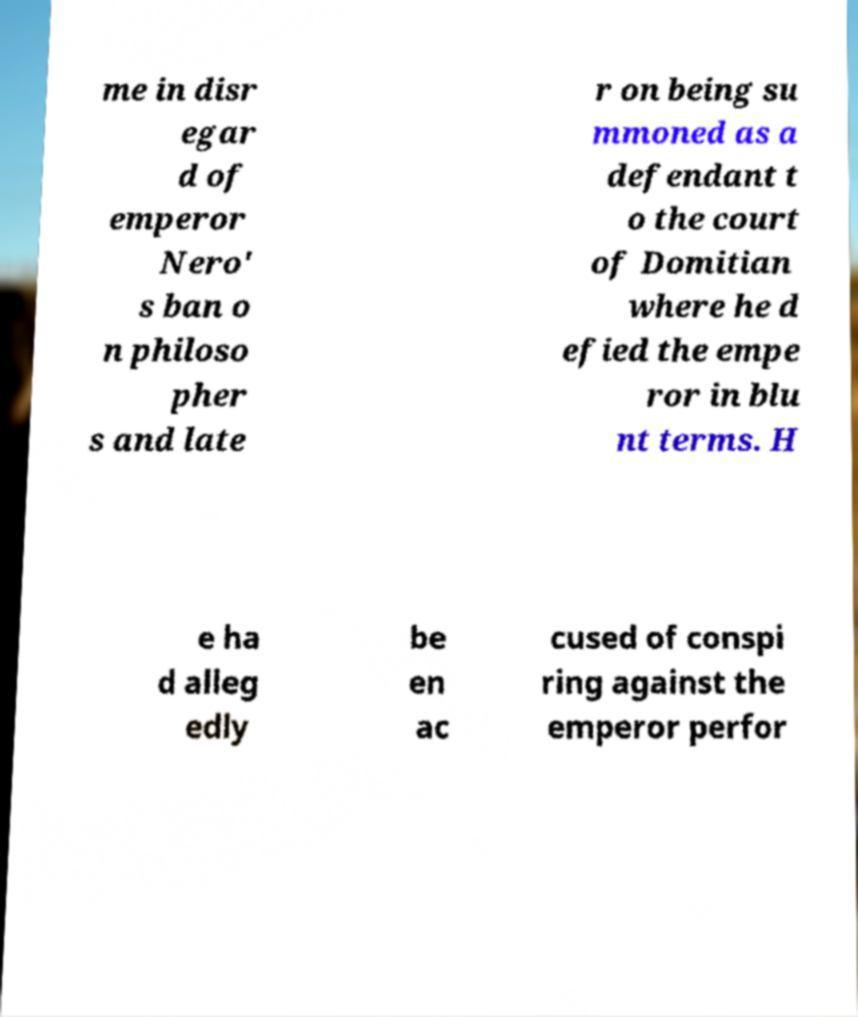Can you accurately transcribe the text from the provided image for me? me in disr egar d of emperor Nero' s ban o n philoso pher s and late r on being su mmoned as a defendant t o the court of Domitian where he d efied the empe ror in blu nt terms. H e ha d alleg edly be en ac cused of conspi ring against the emperor perfor 